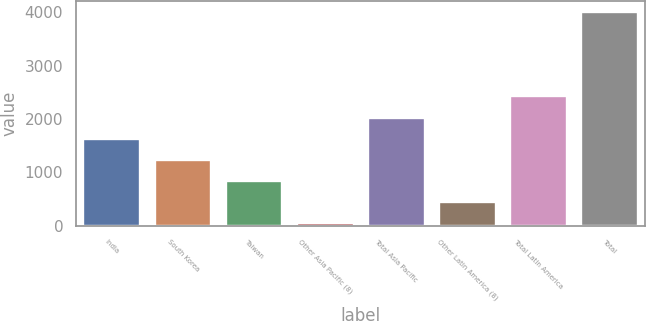<chart> <loc_0><loc_0><loc_500><loc_500><bar_chart><fcel>India<fcel>South Korea<fcel>Taiwan<fcel>Other Asia Pacific (8)<fcel>Total Asia Pacific<fcel>Other Latin America (8)<fcel>Total Latin America<fcel>Total<nl><fcel>1630.8<fcel>1234.6<fcel>838.4<fcel>46<fcel>2027<fcel>442.2<fcel>2423.2<fcel>4008<nl></chart> 